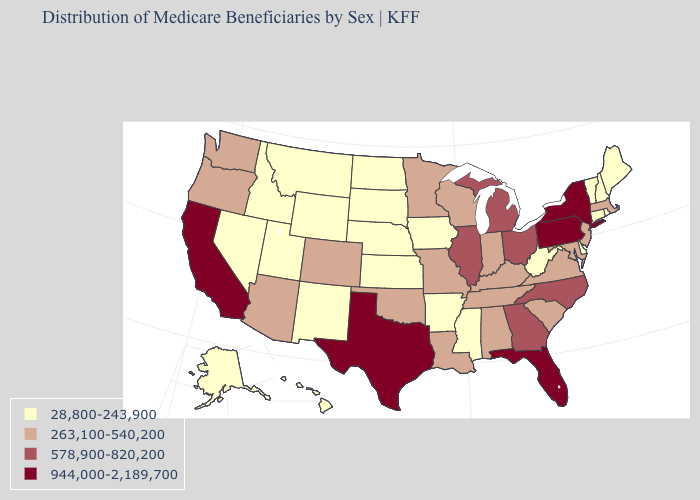What is the highest value in states that border Pennsylvania?
Give a very brief answer. 944,000-2,189,700. Among the states that border Missouri , which have the highest value?
Quick response, please. Illinois. Does the map have missing data?
Keep it brief. No. Which states have the lowest value in the MidWest?
Quick response, please. Iowa, Kansas, Nebraska, North Dakota, South Dakota. What is the lowest value in the USA?
Write a very short answer. 28,800-243,900. Name the states that have a value in the range 263,100-540,200?
Quick response, please. Alabama, Arizona, Colorado, Indiana, Kentucky, Louisiana, Maryland, Massachusetts, Minnesota, Missouri, New Jersey, Oklahoma, Oregon, South Carolina, Tennessee, Virginia, Washington, Wisconsin. What is the value of Utah?
Concise answer only. 28,800-243,900. Is the legend a continuous bar?
Give a very brief answer. No. What is the value of North Carolina?
Short answer required. 578,900-820,200. Which states have the highest value in the USA?
Write a very short answer. California, Florida, New York, Pennsylvania, Texas. Which states have the highest value in the USA?
Quick response, please. California, Florida, New York, Pennsylvania, Texas. Which states hav the highest value in the MidWest?
Short answer required. Illinois, Michigan, Ohio. What is the value of Massachusetts?
Answer briefly. 263,100-540,200. What is the value of Maryland?
Answer briefly. 263,100-540,200. What is the lowest value in the West?
Quick response, please. 28,800-243,900. 